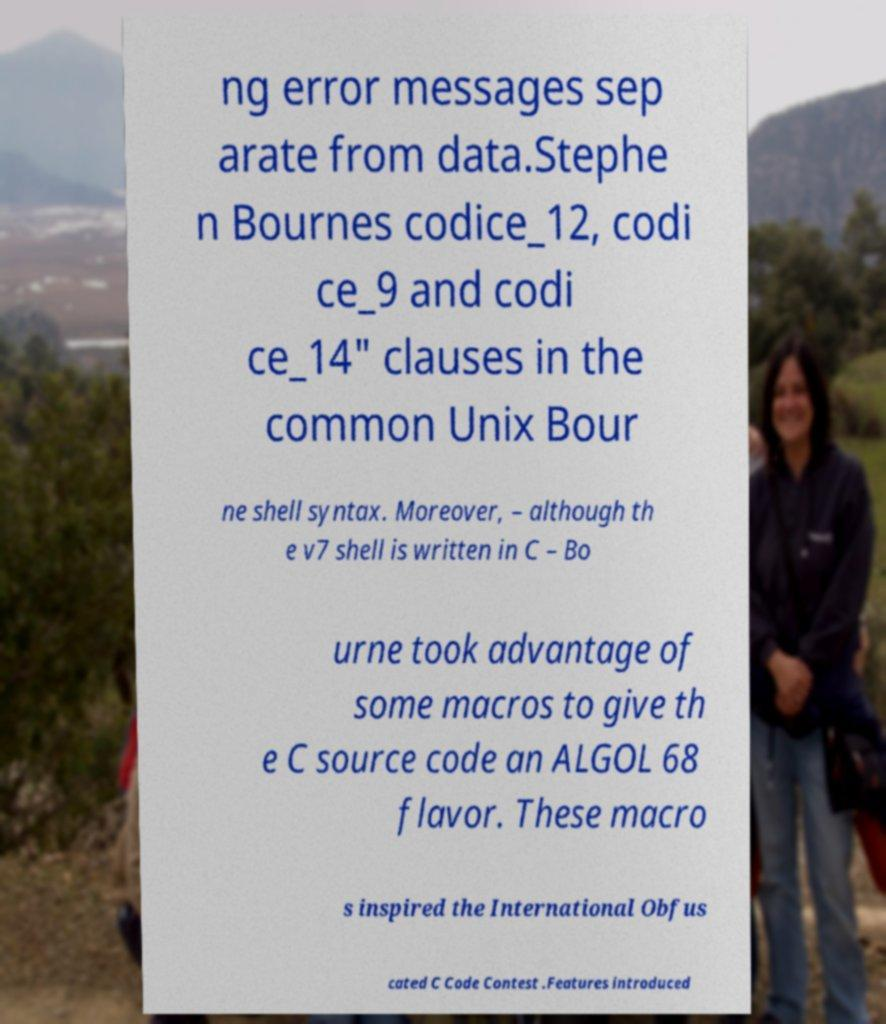Could you extract and type out the text from this image? ng error messages sep arate from data.Stephe n Bournes codice_12, codi ce_9 and codi ce_14" clauses in the common Unix Bour ne shell syntax. Moreover, – although th e v7 shell is written in C – Bo urne took advantage of some macros to give th e C source code an ALGOL 68 flavor. These macro s inspired the International Obfus cated C Code Contest .Features introduced 